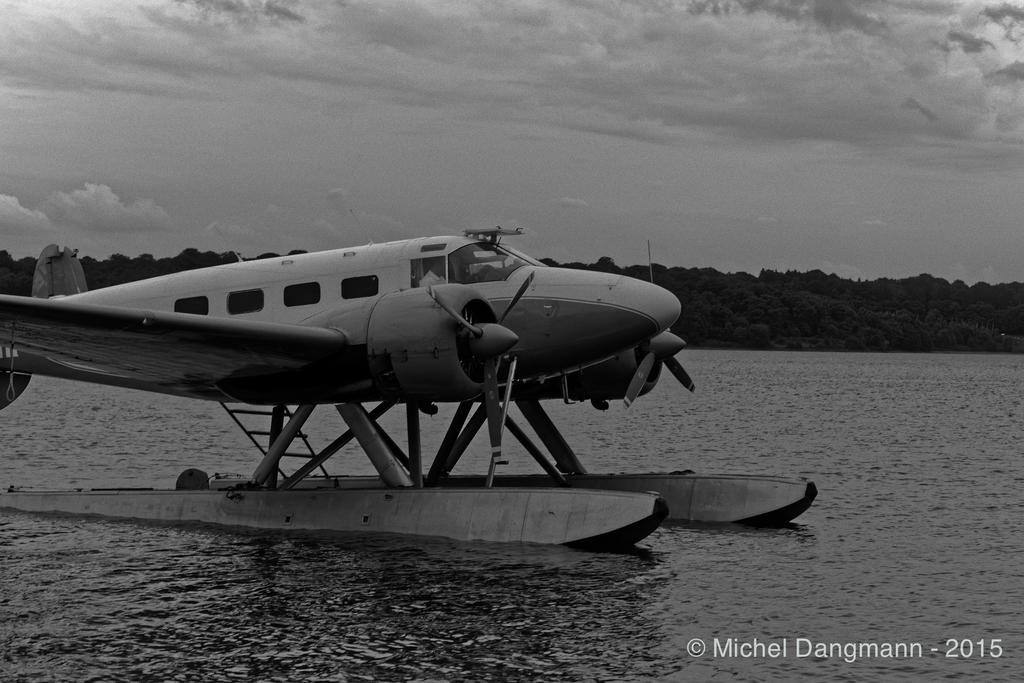What is the color scheme of the image? The image is black and white. What is the main subject in the image? There is an aircraft in the water. What can be seen in the background of the image? There are trees in the background. What is visible at the top of the image? The sky is visible at the top of the image. How many pairs of underwear can be seen in the image? There are no underwear visible in the image. What type of airplane is running on the water in the image? There is no airplane running on the water in the image; it is an aircraft submerged in the water. 